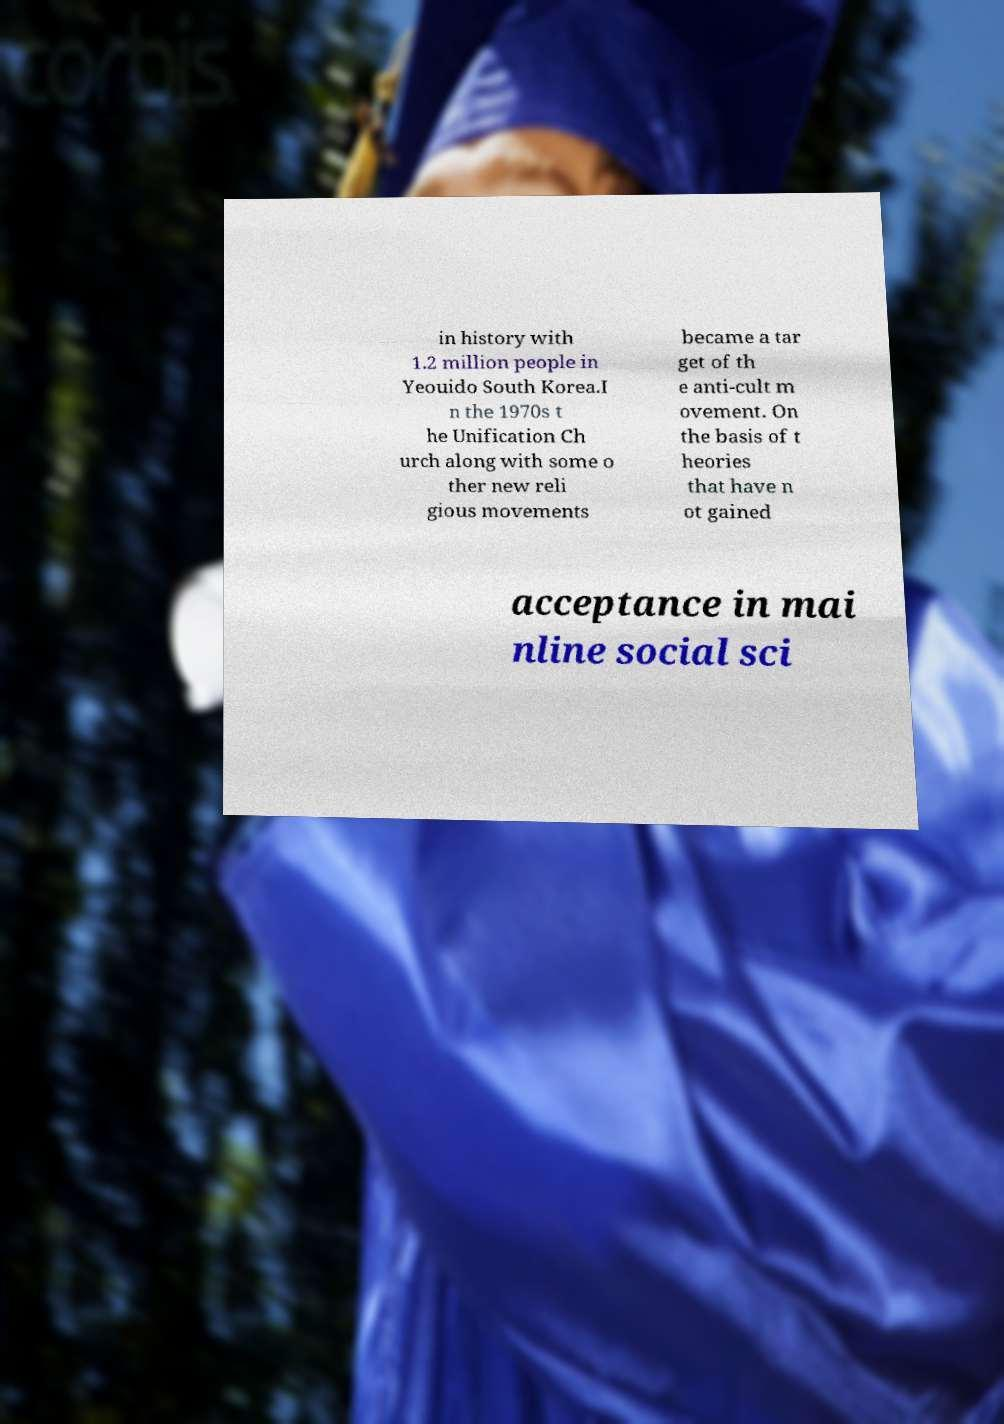For documentation purposes, I need the text within this image transcribed. Could you provide that? in history with 1.2 million people in Yeouido South Korea.I n the 1970s t he Unification Ch urch along with some o ther new reli gious movements became a tar get of th e anti-cult m ovement. On the basis of t heories that have n ot gained acceptance in mai nline social sci 